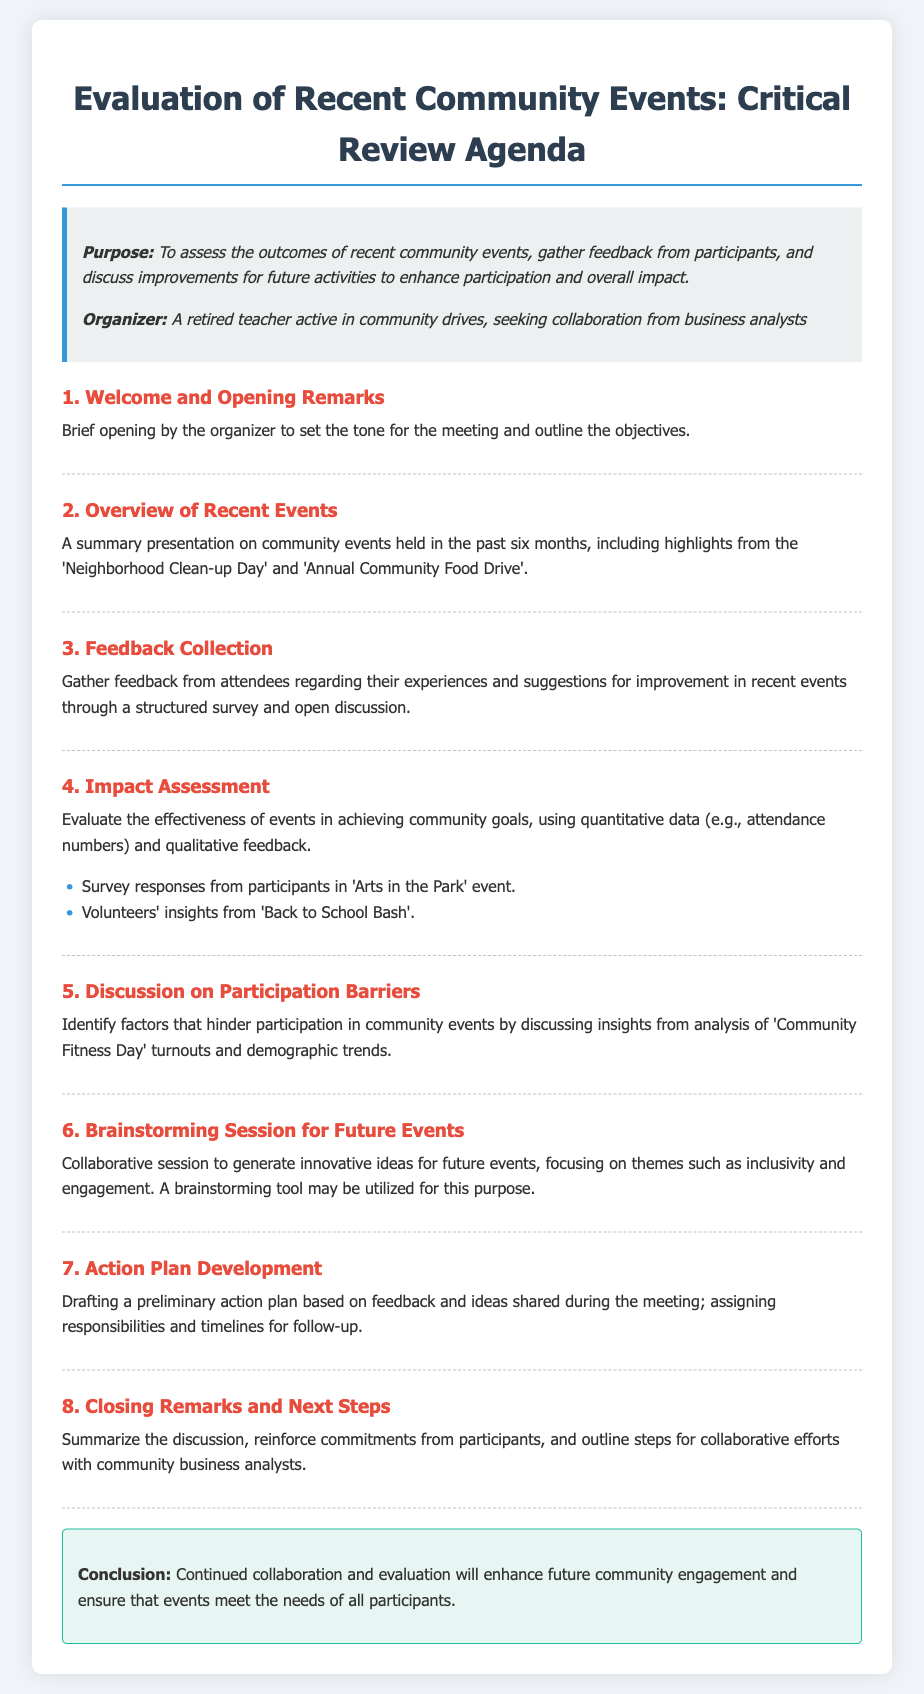What is the purpose of the meeting? The purpose is to assess the outcomes of recent community events, gather feedback from participants, and discuss improvements for future activities to enhance participation and overall impact.
Answer: Assess the outcomes of recent community events Who is the organizer of the meeting? The organizer is identified in the introduction section of the document, outlining their role within the community.
Answer: A retired teacher active in community drives What is the first agenda item? The first item on the agenda, which sets the tone for the meeting.
Answer: Welcome and Opening Remarks How many recent community events are summarized in the overview? The overview presents highlights from specific events that have occurred recently.
Answer: Two What type of session is included to generate ideas for future events? The agenda specifies a method to encourage open sharing of innovative event ideas among participants.
Answer: Brainstorming Session What are the two specific events mentioned under impact assessment? The document lists particular events to evaluate their impact within the community.
Answer: Arts in the Park and Back to School Bash What is the last agenda item? The concluding item summarizes the discussions and outlines collaborative steps.
Answer: Closing Remarks and Next Steps What color is used for the headings of agenda items? The document is designed with a specific color for section headings to enhance readability.
Answer: Red 